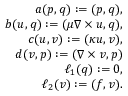Convert formula to latex. <formula><loc_0><loc_0><loc_500><loc_500>\begin{array} { r l r } & { a ( p , q ) \colon = ( p , q ) , } \\ & { b ( u , q ) \colon = ( \mu \nabla \times u , q ) , } \\ & { c ( u , v ) \colon = ( \kappa u , v ) , } \\ & { d ( v , p ) \colon = ( \nabla \times v , p ) } \\ & { \ell _ { 1 } ( q ) \colon = 0 , } \\ & { \ell _ { 2 } ( v ) \colon = ( f , v ) . } \end{array}</formula> 